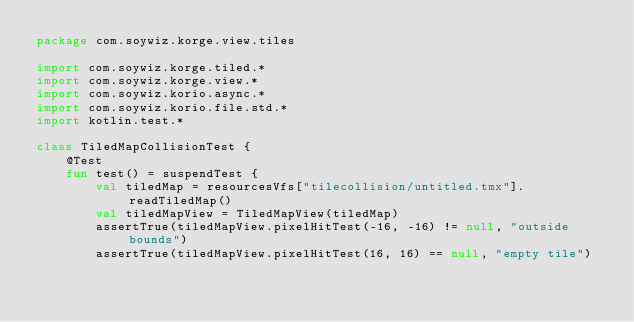Convert code to text. <code><loc_0><loc_0><loc_500><loc_500><_Kotlin_>package com.soywiz.korge.view.tiles

import com.soywiz.korge.tiled.*
import com.soywiz.korge.view.*
import com.soywiz.korio.async.*
import com.soywiz.korio.file.std.*
import kotlin.test.*

class TiledMapCollisionTest {
    @Test
    fun test() = suspendTest {
        val tiledMap = resourcesVfs["tilecollision/untitled.tmx"].readTiledMap()
        val tiledMapView = TiledMapView(tiledMap)
        assertTrue(tiledMapView.pixelHitTest(-16, -16) != null, "outside bounds")
        assertTrue(tiledMapView.pixelHitTest(16, 16) == null, "empty tile")</code> 